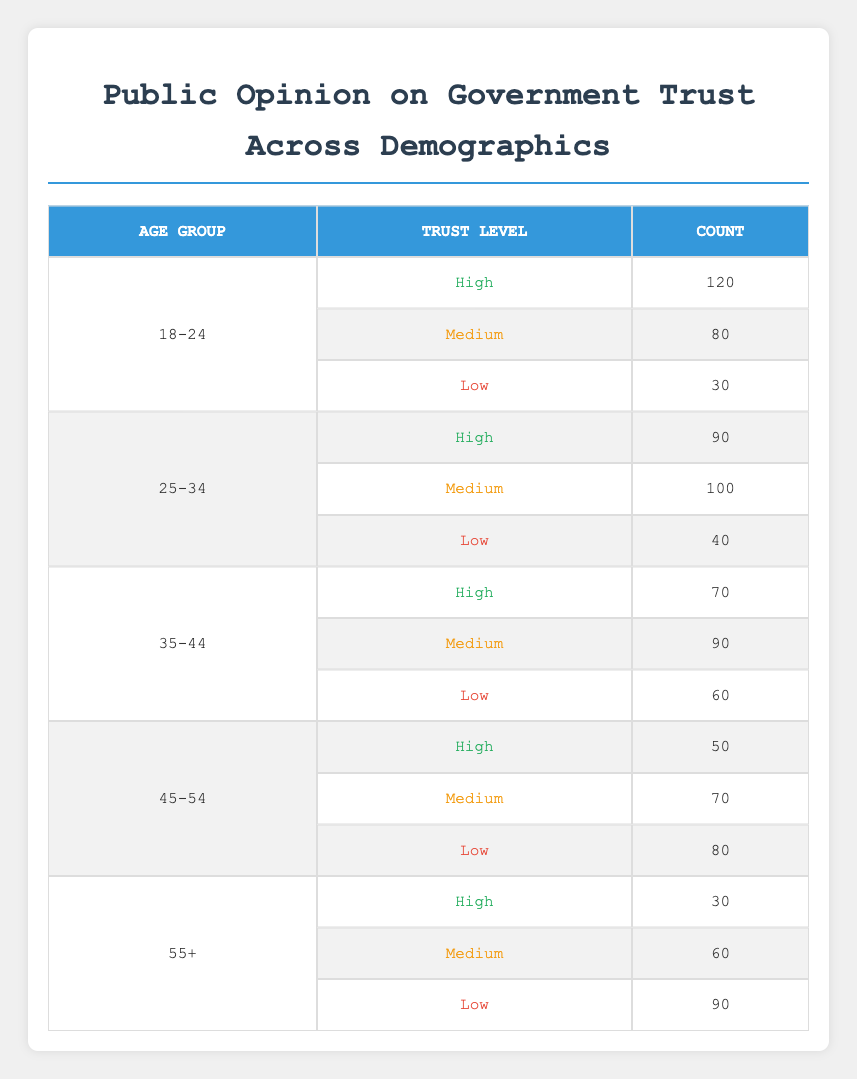What is the total count of individuals in the age group 18-24? By looking at the age group 18-24, we see that the counts are 120 for high trust, 80 for medium trust, and 30 for low trust. Adding these counts together: 120 + 80 + 30 = 230, gives us the total for this age group.
Answer: 230 Which trust level has the highest count in the age group 25-34? For the age group 25-34, the counts are 90 for high trust, 100 for medium trust, and 40 for low trust. The highest of these counts is 100 for medium trust.
Answer: Medium Is the count of individuals who have high trust in the age group 45-54 greater than those who have low trust? In the age group 45-54, there are 50 individuals with high trust and 80 individuals with low trust. Since 50 is not greater than 80, the statement is false.
Answer: No What is the average count of individuals across all trust levels for the age group 35-44? For the age group 35-44, the counts are 70 for high trust, 90 for medium trust, and 60 for low trust. To find the average, we sum these counts: 70 + 90 + 60 = 220. There are 3 trust levels, so we calculate the average as 220/3 = approximately 73.33.
Answer: 73.33 Which age group has the lowest total count across all trust levels? We compute the total counts for each age group: 18-24 = 230, 25-34 = 230, 35-44 = 220, 45-54 = 200, and 55+ = 180. The lowest total count is 180 for the age group 55+.
Answer: 55+ Are there more individuals in the age group 35-44 with medium trust than in the age group 45-54 with high trust? The count for medium trust in the age group 35-44 is 90, while the count for high trust in the age group 45-54 is 50. So, comparing these two values shows that 90 is greater than 50, making the statement true.
Answer: Yes What is the difference in count for individuals with low trust between age groups 25-34 and 55+? The count for low trust in the age group 25-34 is 40, and for 55+, it is 90. We find the difference by subtracting: 90 - 40 = 50. Thus, there are 50 more individuals with low trust in the 55+ age group than in the 25-34 age group.
Answer: 50 In which age group is the count for high trust the lowest? By evaluating the counts for high trust across age groups: 120 (18-24), 90 (25-34), 70 (35-44), 50 (45-54), and 30 (55+), we can see that the lowest count for high trust is 30 in the age group 55+.
Answer: 55+ What percentage of individuals in the 45-54 age group have high trust? To calculate the percentage, we first sum the counts for the 45-54 age group: 50 (high) + 70 (medium) + 80 (low) = 200. The number with high trust is 50. We calculate the percentage as (50 / 200) * 100 = 25%.
Answer: 25% 